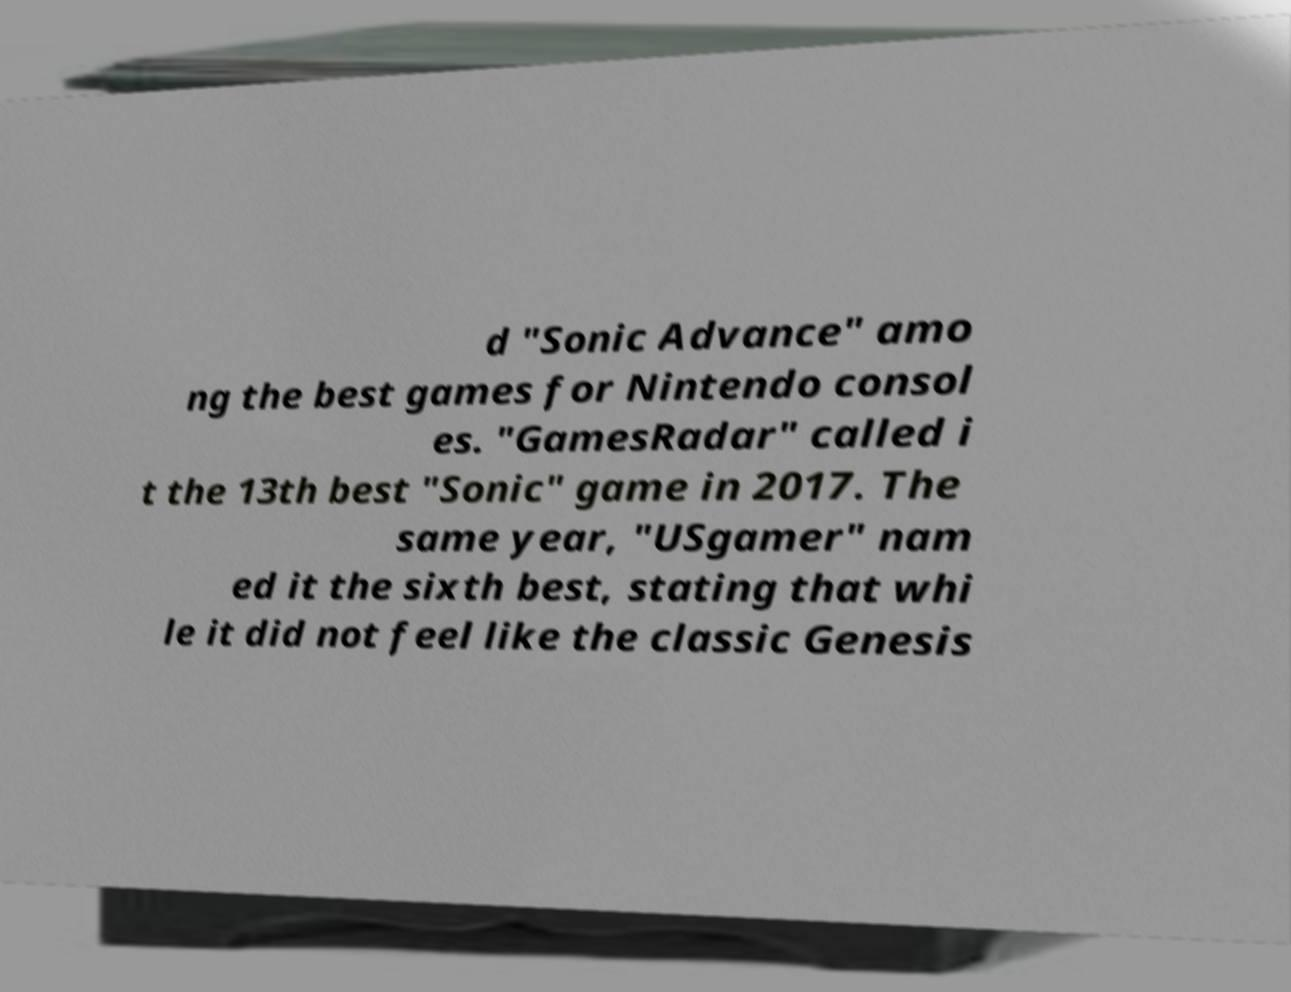Could you assist in decoding the text presented in this image and type it out clearly? d "Sonic Advance" amo ng the best games for Nintendo consol es. "GamesRadar" called i t the 13th best "Sonic" game in 2017. The same year, "USgamer" nam ed it the sixth best, stating that whi le it did not feel like the classic Genesis 